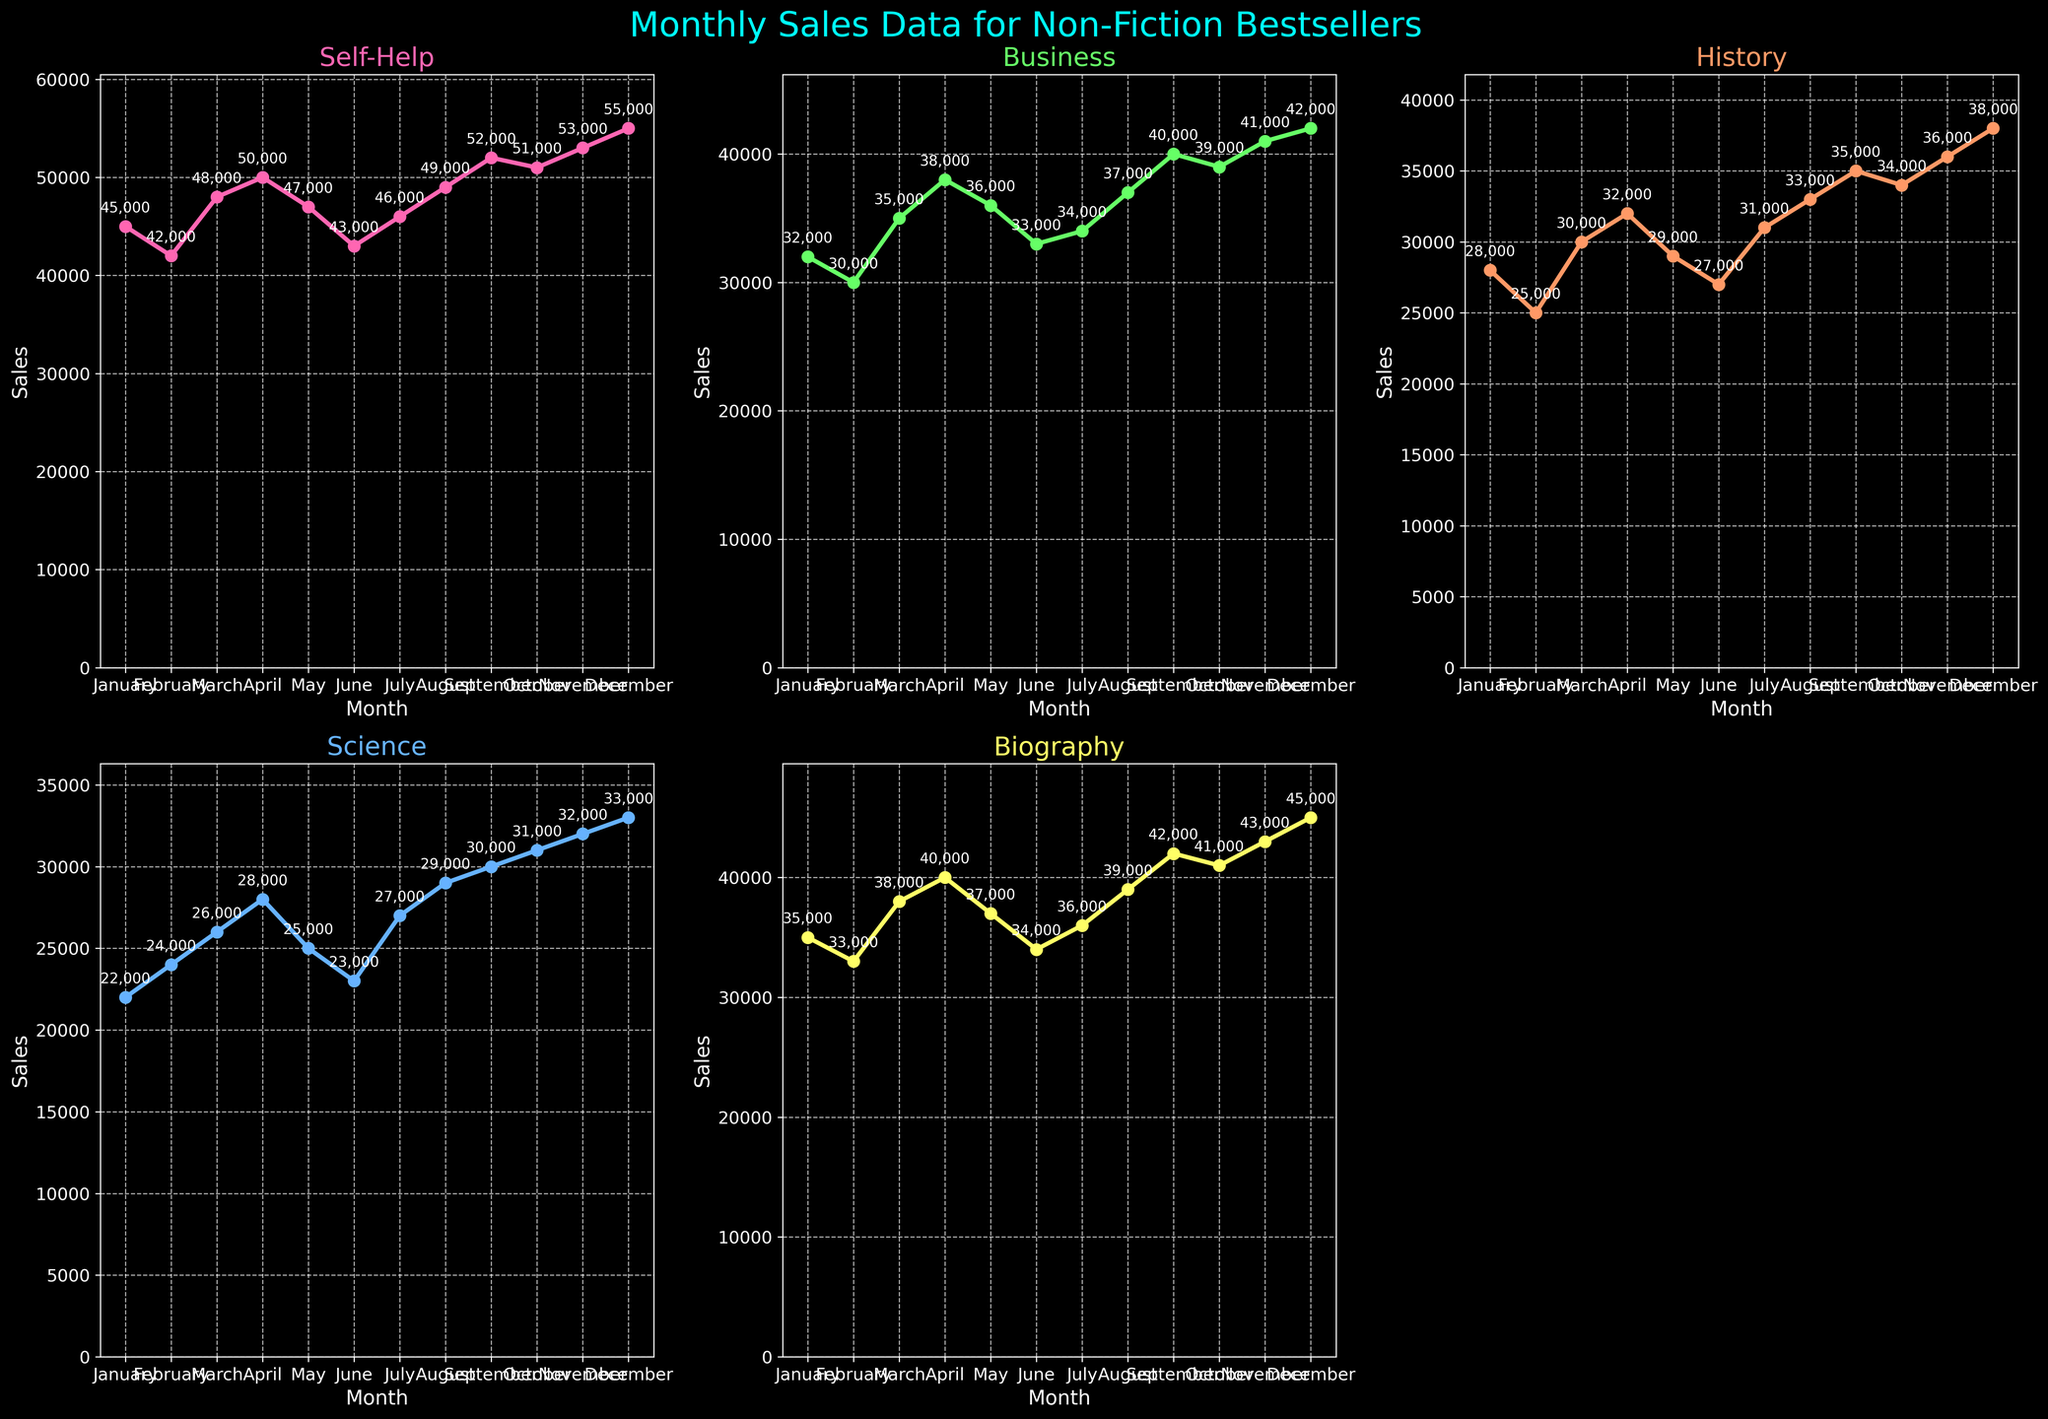What's the title of the figure? The title is found at the top center of the figure, usually in a larger font size and vibrant color. In this case, it reads "Monthly Sales Data for Non-Fiction Bestsellers".
Answer: Monthly Sales Data for Non-Fiction Bestsellers How many genres are plotted in the figure? By counting the number of subplots, which each title a genre name, there are five genres shown in the figure.
Answer: Five Which month had the highest sales for the Biography genre? By looking at the subplot titled "Biography" and finding the highest point on the graph, the month corresponding to this point is December, with 45,000 sales.
Answer: December What is the difference in sales between January and December for the Self-Help genre? For the Self-Help genre subplot, note the sales in January (45,000) and December (55,000). The difference is calculated by subtracting January's sales from December's sales: 55,000 - 45,000.
Answer: 10,000 Which genre had the lowest sales in February? By comparing the second data point in each genre subplot, which represents February, the lowest sales are for the Science genre (24,000).
Answer: Science Which genres have sales that generally increase over time? By observing the general trend direction in each subplot, Self-Help, Business, History, and Biography have an increasing trend, whereas Science has a more fluctuating trend.
Answer: Self-Help, Business, History, Biography What was the total number of sales in July across all genres? Summing up the sales for July from all subplots: Self-Help (46,000), Business (34,000), History (31,000), Science (27,000), Biography (36,000). Thus, the total is 46,000 + 34,000 + 31,000 + 27,000 + 36,000 = 174,000.
Answer: 174,000 In which month did History sales surpass 30,000 for the first time? By tracking the History sales subplot, History sales first surpass 30,000 in March (30,000).
Answer: March How do Science sales in October compare to Science sales in November? Looking at the subplots for Science, comparing October (31,000) and November (32,000), Science sales are higher in November than in October.
Answer: November By how much did Business sales increase from April to December? To find the increase, note Business sales in April (38,000) and December (42,000). The difference is 42,000 - 38,000.
Answer: 4,000 